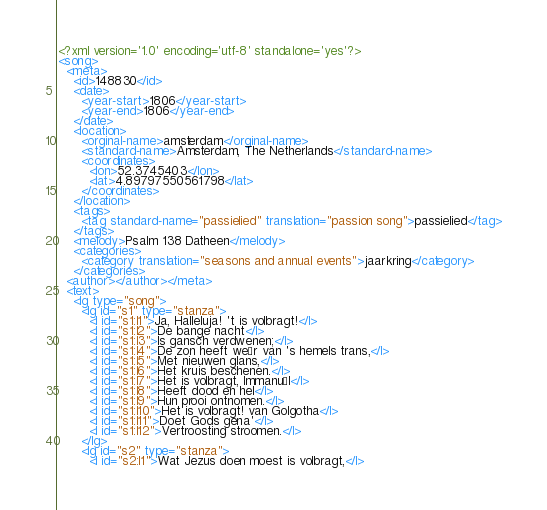Convert code to text. <code><loc_0><loc_0><loc_500><loc_500><_XML_><?xml version='1.0' encoding='utf-8' standalone='yes'?>
<song>
  <meta>
    <id>148830</id>
    <date>
      <year-start>1806</year-start>
      <year-end>1806</year-end>
    </date>
    <location>
      <orginal-name>amsterdam</orginal-name>
      <standard-name>Amsterdam, The Netherlands</standard-name>
      <coordinates>
        <lon>52.3745403</lon>
        <lat>4.89797550561798</lat>
      </coordinates>
    </location>
    <tags>
      <tag standard-name="passielied" translation="passion song">passielied</tag>
    </tags>
    <melody>Psalm 138 Datheen</melody>
    <categories>
      <category translation="seasons and annual events">jaarkring</category>
    </categories>
  <author></author></meta>
  <text>
    <lg type="song">
      <lg id="s1" type="stanza">
        <l id="s1:l1">Ja, Halleluja! 't is volbragt!</l>
        <l id="s1:l2">De bange nacht</l>
        <l id="s1:l3">Is gansch verdwenen;</l>
        <l id="s1:l4">De zon heeft weêr van 's hemels trans,</l>
        <l id="s1:l5">Met nieuwen glans,</l>
        <l id="s1:l6">Het kruis beschenen.</l>
        <l id="s1:l7">Het is volbragt, Immanuël</l>
        <l id="s1:l8">Heeft dood en hel</l>
        <l id="s1:l9">Hun prooi ontnomen.</l>
        <l id="s1:l10">Het is volbragt! van Golgotha</l>
        <l id="s1:l11">Doet Gods gena'</l>
        <l id="s1:l12">Vertroosting stroomen.</l>
      </lg>
      <lg id="s2" type="stanza">
        <l id="s2:l1">Wat Jezus doen moest is volbragt,</l></code> 